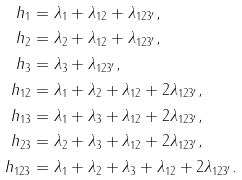<formula> <loc_0><loc_0><loc_500><loc_500>h _ { 1 } & = \lambda _ { 1 } + \lambda _ { 1 2 } + \lambda _ { 1 2 3 ^ { \prime } } , \\ h _ { 2 } & = \lambda _ { 2 } + \lambda _ { 1 2 } + \lambda _ { 1 2 3 ^ { \prime } } , \\ h _ { 3 } & = \lambda _ { 3 } + \lambda _ { 1 2 3 ^ { \prime } } , \\ h _ { 1 2 } & = \lambda _ { 1 } + \lambda _ { 2 } + \lambda _ { 1 2 } + 2 \lambda _ { 1 2 3 ^ { \prime } } , \\ h _ { 1 3 } & = \lambda _ { 1 } + \lambda _ { 3 } + \lambda _ { 1 2 } + 2 \lambda _ { 1 2 3 ^ { \prime } } , \\ h _ { 2 3 } & = \lambda _ { 2 } + \lambda _ { 3 } + \lambda _ { 1 2 } + 2 \lambda _ { 1 2 3 ^ { \prime } } , \\ h _ { 1 2 3 } & = \lambda _ { 1 } + \lambda _ { 2 } + \lambda _ { 3 } + \lambda _ { 1 2 } + 2 \lambda _ { 1 2 3 ^ { \prime } } .</formula> 